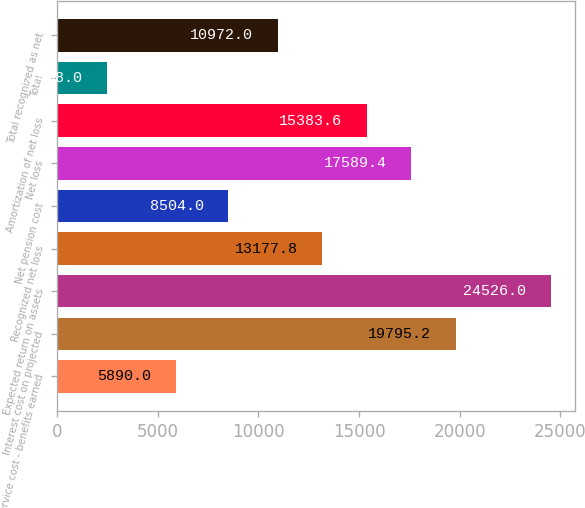Convert chart. <chart><loc_0><loc_0><loc_500><loc_500><bar_chart><fcel>Service cost - benefits earned<fcel>Interest cost on projected<fcel>Expected return on assets<fcel>Recognized net loss<fcel>Net pension cost<fcel>Net loss<fcel>Amortization of net loss<fcel>Total<fcel>Total recognized as net<nl><fcel>5890<fcel>19795.2<fcel>24526<fcel>13177.8<fcel>8504<fcel>17589.4<fcel>15383.6<fcel>2468<fcel>10972<nl></chart> 